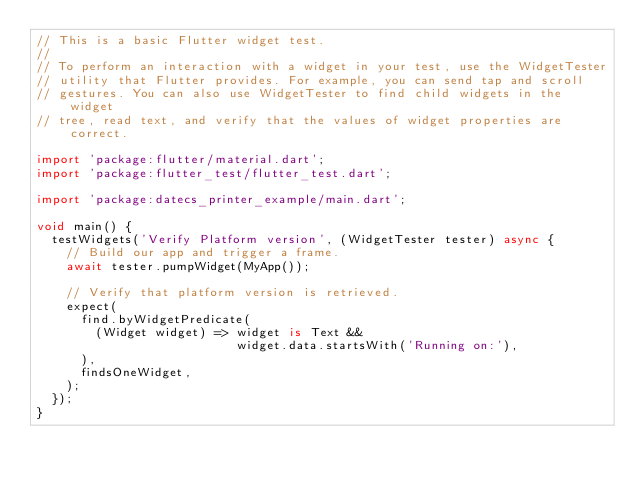<code> <loc_0><loc_0><loc_500><loc_500><_Dart_>// This is a basic Flutter widget test.
//
// To perform an interaction with a widget in your test, use the WidgetTester
// utility that Flutter provides. For example, you can send tap and scroll
// gestures. You can also use WidgetTester to find child widgets in the widget
// tree, read text, and verify that the values of widget properties are correct.

import 'package:flutter/material.dart';
import 'package:flutter_test/flutter_test.dart';

import 'package:datecs_printer_example/main.dart';

void main() {
  testWidgets('Verify Platform version', (WidgetTester tester) async {
    // Build our app and trigger a frame.
    await tester.pumpWidget(MyApp());

    // Verify that platform version is retrieved.
    expect(
      find.byWidgetPredicate(
        (Widget widget) => widget is Text &&
                           widget.data.startsWith('Running on:'),
      ),
      findsOneWidget,
    );
  });
}
</code> 